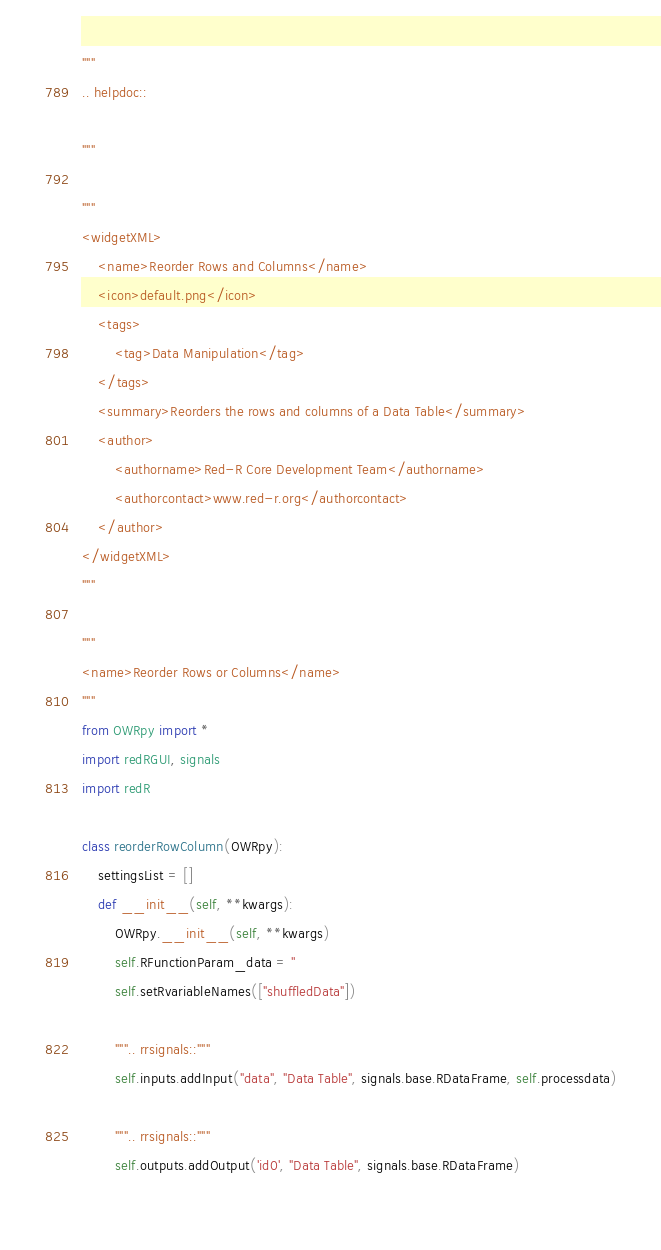Convert code to text. <code><loc_0><loc_0><loc_500><loc_500><_Python_>"""
.. helpdoc::

"""

"""
<widgetXML>    
    <name>Reorder Rows and Columns</name>
    <icon>default.png</icon>
    <tags>
        <tag>Data Manipulation</tag>
    </tags>
    <summary>Reorders the rows and columns of a Data Table</summary>
    <author>
        <authorname>Red-R Core Development Team</authorname>
        <authorcontact>www.red-r.org</authorcontact>
    </author>
</widgetXML>
"""

"""
<name>Reorder Rows or Columns</name>
"""
from OWRpy import * 
import redRGUI, signals
import redR

class reorderRowColumn(OWRpy): 
    settingsList = []
    def __init__(self, **kwargs):
        OWRpy.__init__(self, **kwargs)
        self.RFunctionParam_data = ''
        self.setRvariableNames(["shuffledData"])
        
        """.. rrsignals::"""
        self.inputs.addInput("data", "Data Table", signals.base.RDataFrame, self.processdata)
        
        """.. rrsignals::"""
        self.outputs.addOutput('id0', "Data Table", signals.base.RDataFrame)
        </code> 